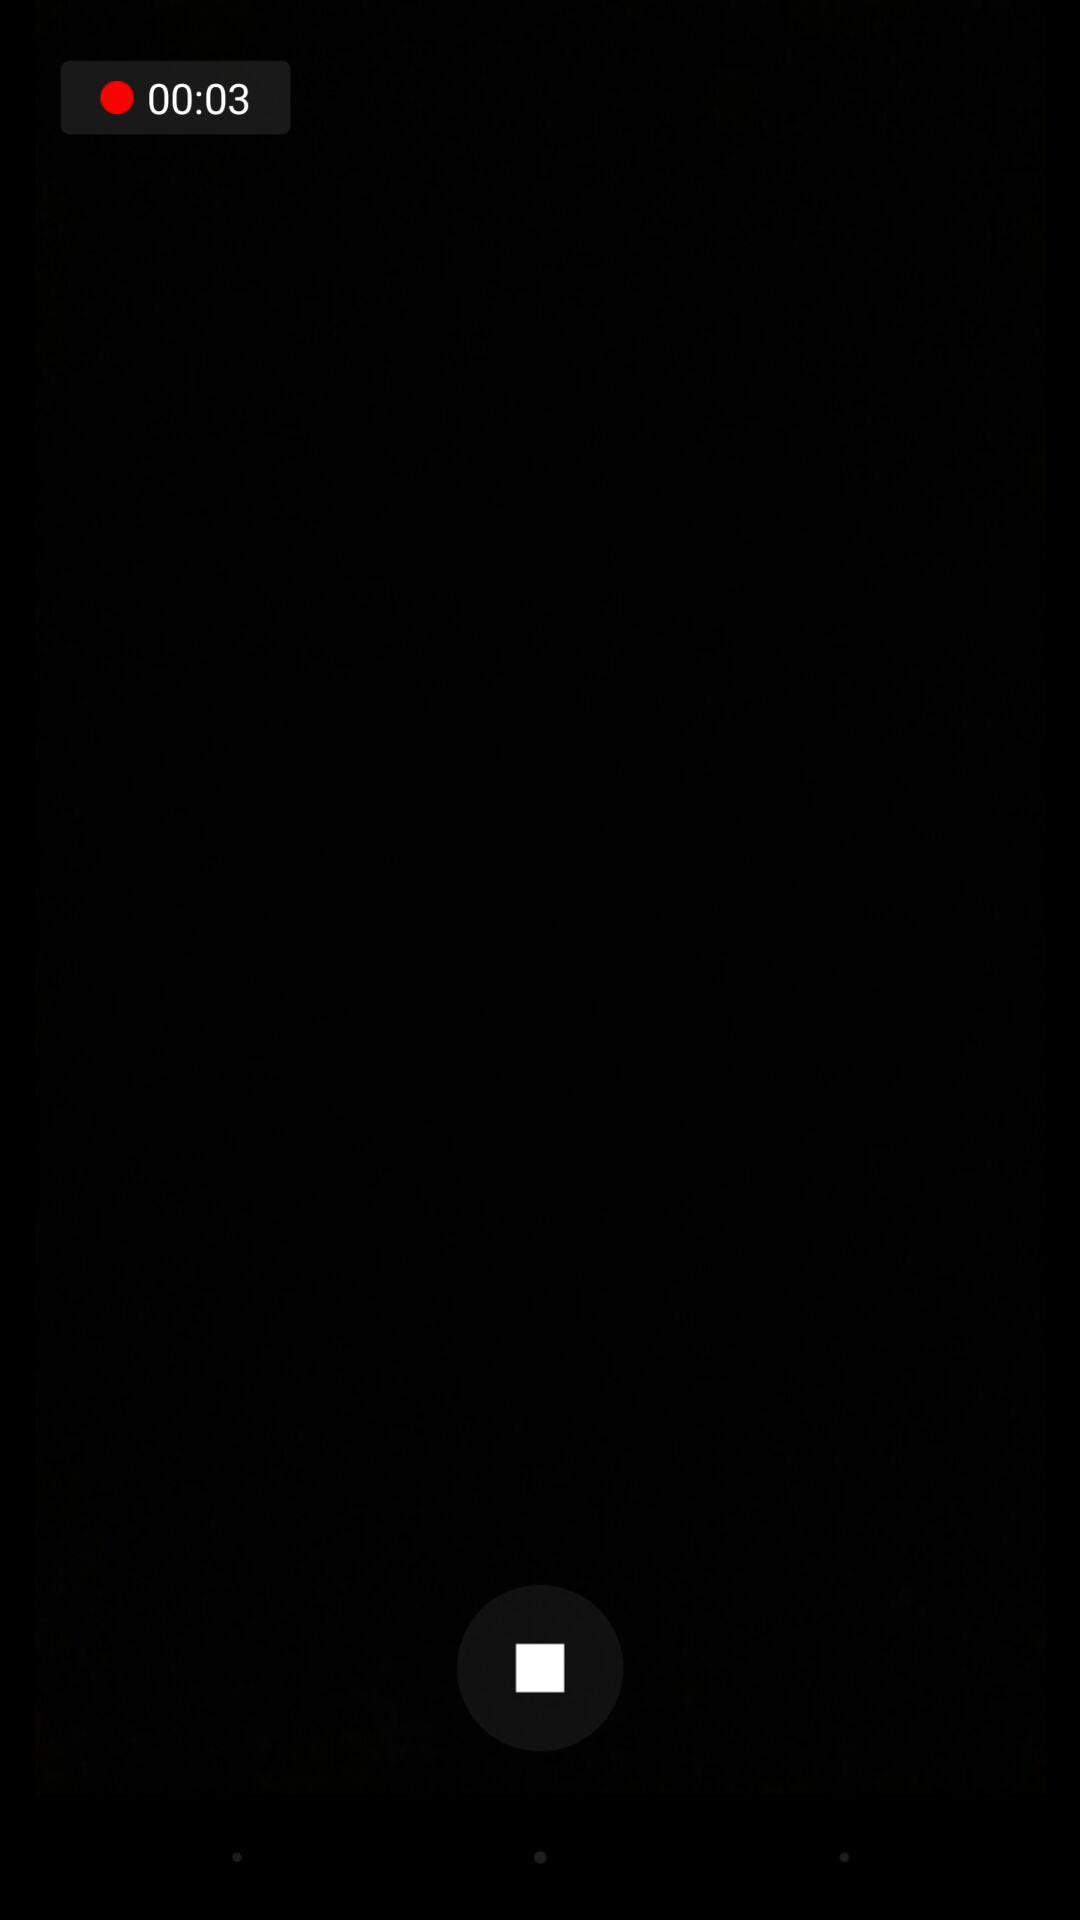How many more seconds until the timer runs out?
Answer the question using a single word or phrase. 3 